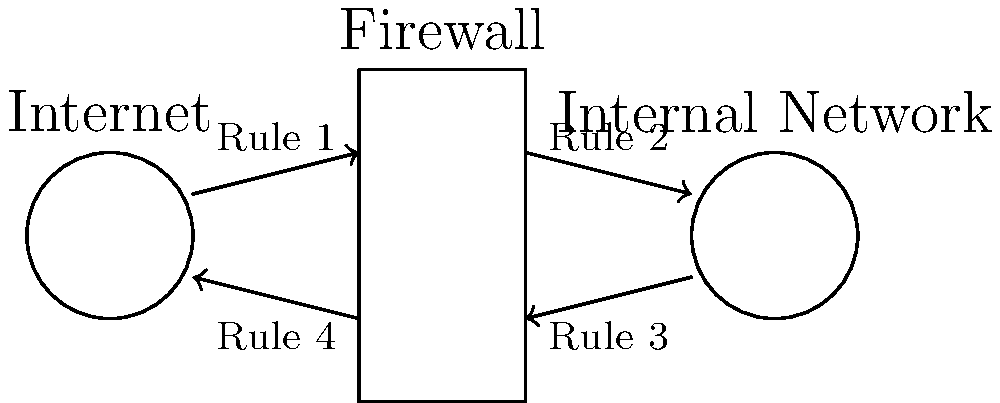In the diagram above, which firewall rule(s) should be configured to allow incoming HTTP traffic (port 80) from the Internet to a web server in the internal network while blocking all other incoming traffic? To configure the firewall for allowing incoming HTTP traffic while blocking all other incoming traffic, we need to follow these steps:

1. Identify the direction of incoming traffic:
   - Incoming traffic from the Internet to the internal network is represented by Rule 1.

2. Understand the requirements:
   - Allow HTTP traffic (port 80)
   - Block all other incoming traffic

3. Configure Rule 1:
   - Allow incoming connections on port 80 (HTTP)
   - Block all other incoming connections

4. Leave other rules unchanged:
   - Rule 2: Outgoing traffic from internal to Internet (typically allowed)
   - Rule 3: Outgoing traffic from internal to Internet (typically allowed)
   - Rule 4: Incoming traffic from Internet to internal (should be blocked by default)

5. The firewall configuration for Rule 1 should look like this:
   - Action: Allow
   - Protocol: TCP
   - Source: Any
   - Destination: Internal Web Server IP
   - Port: 80

6. Add a final rule to block all other incoming traffic:
   - Action: Block
   - Protocol: Any
   - Source: Any
   - Destination: Any
   - Port: Any

By configuring Rule 1 in this manner, we allow incoming HTTP traffic while maintaining security by blocking all other incoming connections.
Answer: Rule 1 